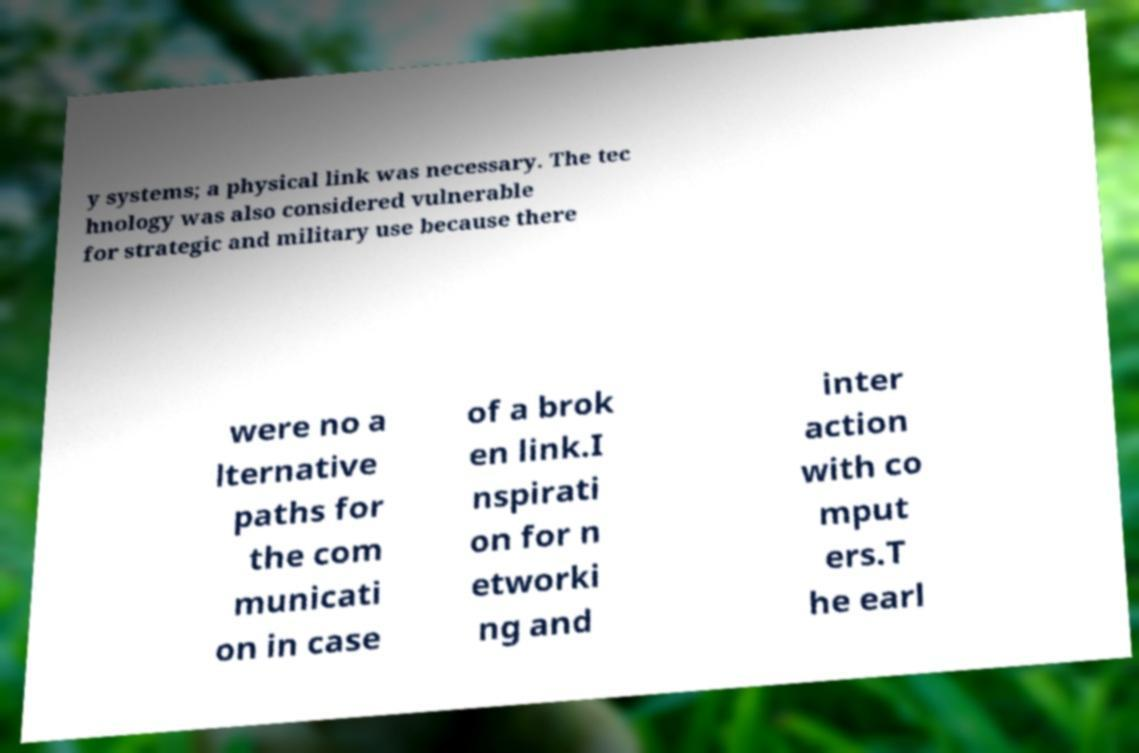Could you extract and type out the text from this image? y systems; a physical link was necessary. The tec hnology was also considered vulnerable for strategic and military use because there were no a lternative paths for the com municati on in case of a brok en link.I nspirati on for n etworki ng and inter action with co mput ers.T he earl 